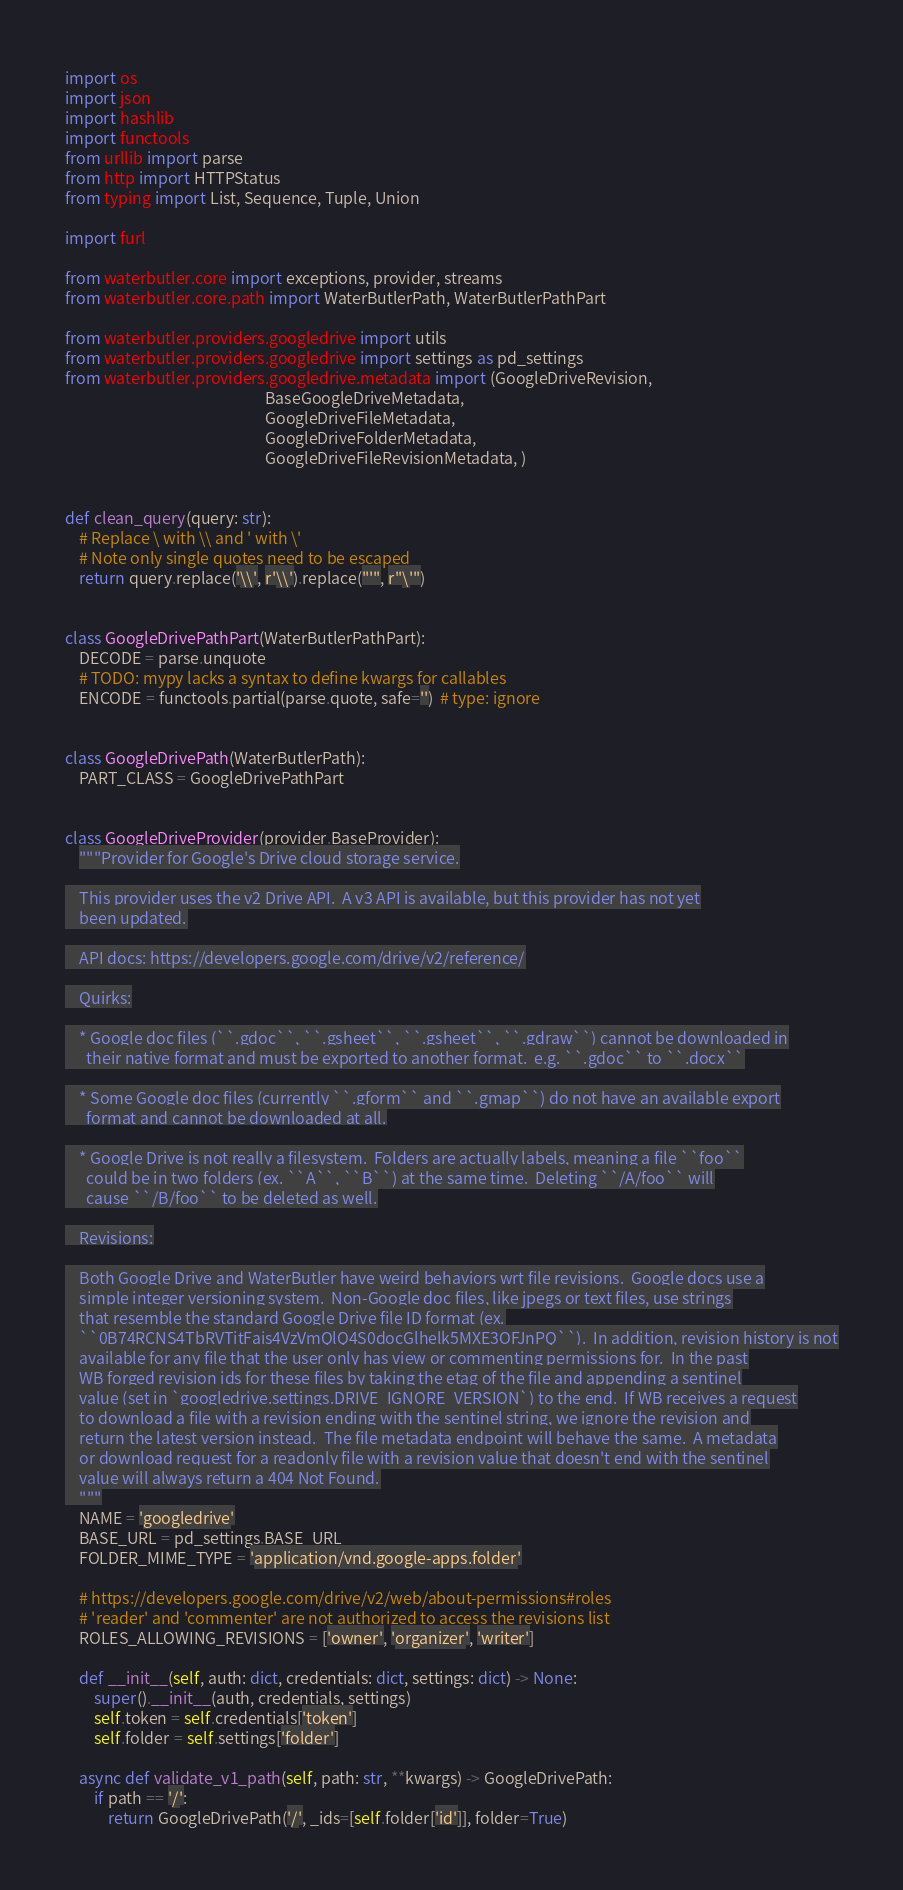Convert code to text. <code><loc_0><loc_0><loc_500><loc_500><_Python_>import os
import json
import hashlib
import functools
from urllib import parse
from http import HTTPStatus
from typing import List, Sequence, Tuple, Union

import furl

from waterbutler.core import exceptions, provider, streams
from waterbutler.core.path import WaterButlerPath, WaterButlerPathPart

from waterbutler.providers.googledrive import utils
from waterbutler.providers.googledrive import settings as pd_settings
from waterbutler.providers.googledrive.metadata import (GoogleDriveRevision,
                                                        BaseGoogleDriveMetadata,
                                                        GoogleDriveFileMetadata,
                                                        GoogleDriveFolderMetadata,
                                                        GoogleDriveFileRevisionMetadata, )


def clean_query(query: str):
    # Replace \ with \\ and ' with \'
    # Note only single quotes need to be escaped
    return query.replace('\\', r'\\').replace("'", r"\'")


class GoogleDrivePathPart(WaterButlerPathPart):
    DECODE = parse.unquote
    # TODO: mypy lacks a syntax to define kwargs for callables
    ENCODE = functools.partial(parse.quote, safe='')  # type: ignore


class GoogleDrivePath(WaterButlerPath):
    PART_CLASS = GoogleDrivePathPart


class GoogleDriveProvider(provider.BaseProvider):
    """Provider for Google's Drive cloud storage service.

    This provider uses the v2 Drive API.  A v3 API is available, but this provider has not yet
    been updated.

    API docs: https://developers.google.com/drive/v2/reference/

    Quirks:

    * Google doc files (``.gdoc``, ``.gsheet``, ``.gsheet``, ``.gdraw``) cannot be downloaded in
      their native format and must be exported to another format.  e.g. ``.gdoc`` to ``.docx``

    * Some Google doc files (currently ``.gform`` and ``.gmap``) do not have an available export
      format and cannot be downloaded at all.

    * Google Drive is not really a filesystem.  Folders are actually labels, meaning a file ``foo``
      could be in two folders (ex. ``A``, ``B``) at the same time.  Deleting ``/A/foo`` will
      cause ``/B/foo`` to be deleted as well.

    Revisions:

    Both Google Drive and WaterButler have weird behaviors wrt file revisions.  Google docs use a
    simple integer versioning system.  Non-Google doc files, like jpegs or text files, use strings
    that resemble the standard Google Drive file ID format (ex.
    ``0B74RCNS4TbRVTitFais4VzVmQlQ4S0docGlhelk5MXE3OFJnPQ``).  In addition, revision history is not
    available for any file that the user only has view or commenting permissions for.  In the past
    WB forged revision ids for these files by taking the etag of the file and appending a sentinel
    value (set in `googledrive.settings.DRIVE_IGNORE_VERSION`) to the end.  If WB receives a request
    to download a file with a revision ending with the sentinel string, we ignore the revision and
    return the latest version instead.  The file metadata endpoint will behave the same.  A metadata
    or download request for a readonly file with a revision value that doesn't end with the sentinel
    value will always return a 404 Not Found.
    """
    NAME = 'googledrive'
    BASE_URL = pd_settings.BASE_URL
    FOLDER_MIME_TYPE = 'application/vnd.google-apps.folder'

    # https://developers.google.com/drive/v2/web/about-permissions#roles
    # 'reader' and 'commenter' are not authorized to access the revisions list
    ROLES_ALLOWING_REVISIONS = ['owner', 'organizer', 'writer']

    def __init__(self, auth: dict, credentials: dict, settings: dict) -> None:
        super().__init__(auth, credentials, settings)
        self.token = self.credentials['token']
        self.folder = self.settings['folder']

    async def validate_v1_path(self, path: str, **kwargs) -> GoogleDrivePath:
        if path == '/':
            return GoogleDrivePath('/', _ids=[self.folder['id']], folder=True)
</code> 